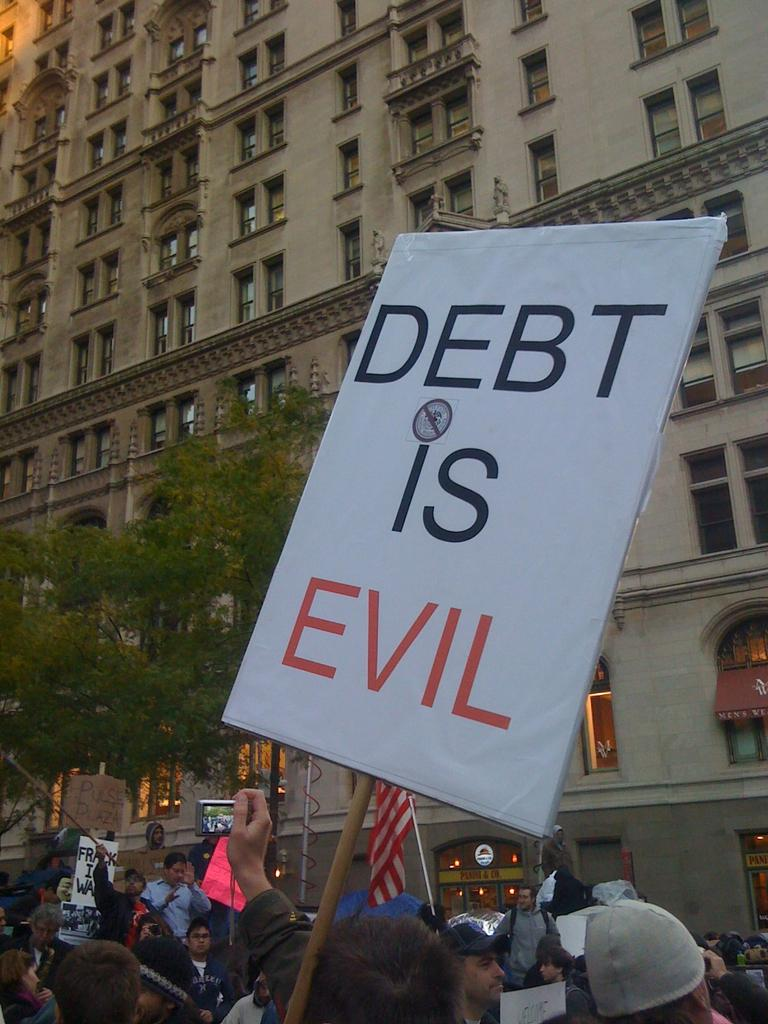Who or what can be seen in the image? There are people in the image. What structures are present in the image? There are posts, a building, and a pole in the image. What is attached to the pole in the image? There is a flag attached to the pole in the image. What type of vegetation is visible in the image? There are trees in the image. What else can be seen in the image? There is a wire in the image. What type of decision can be seen being made by the celery in the image? There is no celery present in the image, and therefore no decision-making can be observed. What color is the patch on the building in the image? There is no mention of a patch on the building in the image, so we cannot determine its color. 